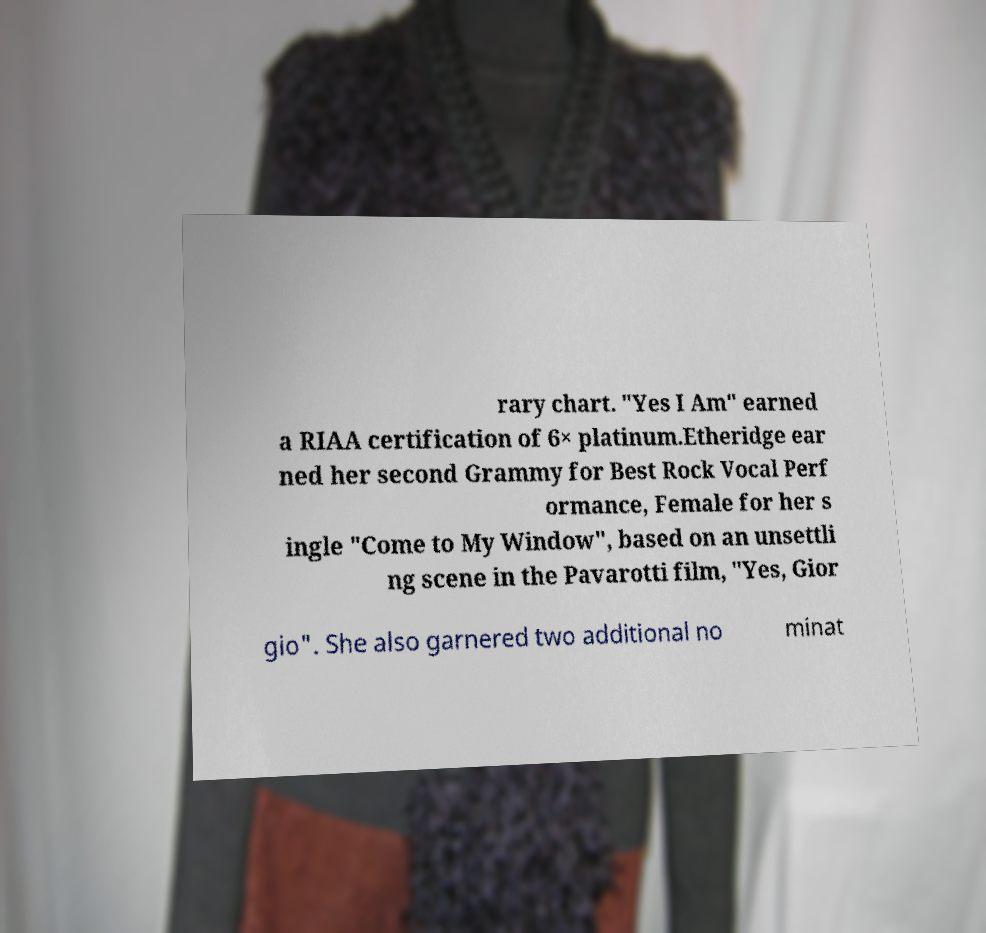For documentation purposes, I need the text within this image transcribed. Could you provide that? rary chart. "Yes I Am" earned a RIAA certification of 6× platinum.Etheridge ear ned her second Grammy for Best Rock Vocal Perf ormance, Female for her s ingle "Come to My Window", based on an unsettli ng scene in the Pavarotti film, "Yes, Gior gio". She also garnered two additional no minat 